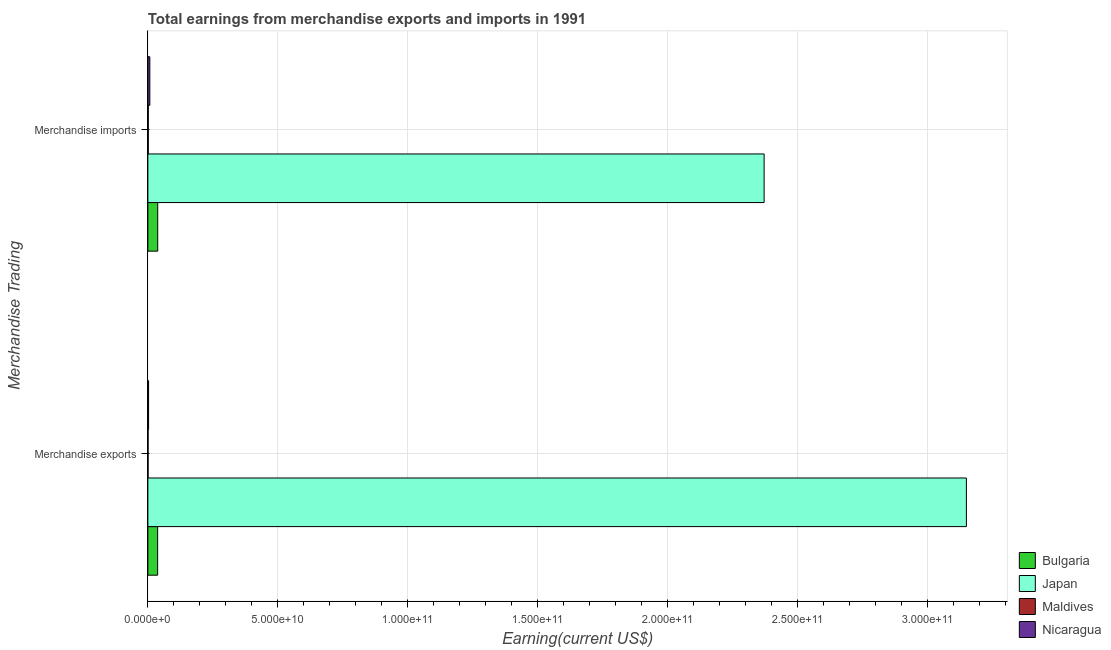How many different coloured bars are there?
Provide a short and direct response. 4. How many groups of bars are there?
Offer a terse response. 2. How many bars are there on the 1st tick from the bottom?
Ensure brevity in your answer.  4. What is the earnings from merchandise exports in Japan?
Provide a short and direct response. 3.15e+11. Across all countries, what is the maximum earnings from merchandise exports?
Ensure brevity in your answer.  3.15e+11. Across all countries, what is the minimum earnings from merchandise imports?
Offer a terse response. 1.61e+08. In which country was the earnings from merchandise imports minimum?
Offer a terse response. Maldives. What is the total earnings from merchandise imports in the graph?
Give a very brief answer. 2.42e+11. What is the difference between the earnings from merchandise imports in Maldives and that in Bulgaria?
Provide a succinct answer. -3.63e+09. What is the difference between the earnings from merchandise exports in Japan and the earnings from merchandise imports in Maldives?
Your response must be concise. 3.15e+11. What is the average earnings from merchandise imports per country?
Give a very brief answer. 6.04e+1. What is the difference between the earnings from merchandise exports and earnings from merchandise imports in Japan?
Your answer should be compact. 7.78e+1. In how many countries, is the earnings from merchandise imports greater than 220000000000 US$?
Offer a terse response. 1. What is the ratio of the earnings from merchandise imports in Bulgaria to that in Japan?
Your answer should be very brief. 0.02. What does the 1st bar from the top in Merchandise imports represents?
Make the answer very short. Nicaragua. What does the 4th bar from the bottom in Merchandise exports represents?
Your answer should be compact. Nicaragua. How many countries are there in the graph?
Your answer should be compact. 4. Does the graph contain any zero values?
Your answer should be very brief. No. What is the title of the graph?
Ensure brevity in your answer.  Total earnings from merchandise exports and imports in 1991. Does "Samoa" appear as one of the legend labels in the graph?
Ensure brevity in your answer.  No. What is the label or title of the X-axis?
Make the answer very short. Earning(current US$). What is the label or title of the Y-axis?
Offer a very short reply. Merchandise Trading. What is the Earning(current US$) in Bulgaria in Merchandise exports?
Make the answer very short. 3.76e+09. What is the Earning(current US$) of Japan in Merchandise exports?
Give a very brief answer. 3.15e+11. What is the Earning(current US$) in Maldives in Merchandise exports?
Offer a terse response. 7.62e+07. What is the Earning(current US$) of Nicaragua in Merchandise exports?
Your response must be concise. 2.72e+08. What is the Earning(current US$) of Bulgaria in Merchandise imports?
Provide a succinct answer. 3.79e+09. What is the Earning(current US$) of Japan in Merchandise imports?
Make the answer very short. 2.37e+11. What is the Earning(current US$) in Maldives in Merchandise imports?
Provide a short and direct response. 1.61e+08. What is the Earning(current US$) in Nicaragua in Merchandise imports?
Give a very brief answer. 7.51e+08. Across all Merchandise Trading, what is the maximum Earning(current US$) in Bulgaria?
Provide a succinct answer. 3.79e+09. Across all Merchandise Trading, what is the maximum Earning(current US$) of Japan?
Your answer should be very brief. 3.15e+11. Across all Merchandise Trading, what is the maximum Earning(current US$) in Maldives?
Provide a short and direct response. 1.61e+08. Across all Merchandise Trading, what is the maximum Earning(current US$) in Nicaragua?
Your answer should be very brief. 7.51e+08. Across all Merchandise Trading, what is the minimum Earning(current US$) of Bulgaria?
Make the answer very short. 3.76e+09. Across all Merchandise Trading, what is the minimum Earning(current US$) of Japan?
Offer a terse response. 2.37e+11. Across all Merchandise Trading, what is the minimum Earning(current US$) in Maldives?
Provide a succinct answer. 7.62e+07. Across all Merchandise Trading, what is the minimum Earning(current US$) of Nicaragua?
Make the answer very short. 2.72e+08. What is the total Earning(current US$) of Bulgaria in the graph?
Provide a short and direct response. 7.55e+09. What is the total Earning(current US$) of Japan in the graph?
Make the answer very short. 5.52e+11. What is the total Earning(current US$) in Maldives in the graph?
Your response must be concise. 2.37e+08. What is the total Earning(current US$) in Nicaragua in the graph?
Offer a terse response. 1.02e+09. What is the difference between the Earning(current US$) of Bulgaria in Merchandise exports and that in Merchandise imports?
Your response must be concise. -3.00e+07. What is the difference between the Earning(current US$) of Japan in Merchandise exports and that in Merchandise imports?
Offer a terse response. 7.78e+1. What is the difference between the Earning(current US$) of Maldives in Merchandise exports and that in Merchandise imports?
Your response must be concise. -8.48e+07. What is the difference between the Earning(current US$) of Nicaragua in Merchandise exports and that in Merchandise imports?
Provide a short and direct response. -4.79e+08. What is the difference between the Earning(current US$) in Bulgaria in Merchandise exports and the Earning(current US$) in Japan in Merchandise imports?
Offer a terse response. -2.33e+11. What is the difference between the Earning(current US$) in Bulgaria in Merchandise exports and the Earning(current US$) in Maldives in Merchandise imports?
Your response must be concise. 3.60e+09. What is the difference between the Earning(current US$) of Bulgaria in Merchandise exports and the Earning(current US$) of Nicaragua in Merchandise imports?
Give a very brief answer. 3.01e+09. What is the difference between the Earning(current US$) of Japan in Merchandise exports and the Earning(current US$) of Maldives in Merchandise imports?
Offer a very short reply. 3.15e+11. What is the difference between the Earning(current US$) in Japan in Merchandise exports and the Earning(current US$) in Nicaragua in Merchandise imports?
Make the answer very short. 3.14e+11. What is the difference between the Earning(current US$) of Maldives in Merchandise exports and the Earning(current US$) of Nicaragua in Merchandise imports?
Ensure brevity in your answer.  -6.75e+08. What is the average Earning(current US$) in Bulgaria per Merchandise Trading?
Ensure brevity in your answer.  3.78e+09. What is the average Earning(current US$) in Japan per Merchandise Trading?
Give a very brief answer. 2.76e+11. What is the average Earning(current US$) in Maldives per Merchandise Trading?
Offer a very short reply. 1.19e+08. What is the average Earning(current US$) of Nicaragua per Merchandise Trading?
Offer a very short reply. 5.12e+08. What is the difference between the Earning(current US$) of Bulgaria and Earning(current US$) of Japan in Merchandise exports?
Provide a succinct answer. -3.11e+11. What is the difference between the Earning(current US$) of Bulgaria and Earning(current US$) of Maldives in Merchandise exports?
Keep it short and to the point. 3.68e+09. What is the difference between the Earning(current US$) of Bulgaria and Earning(current US$) of Nicaragua in Merchandise exports?
Offer a terse response. 3.49e+09. What is the difference between the Earning(current US$) of Japan and Earning(current US$) of Maldives in Merchandise exports?
Offer a terse response. 3.15e+11. What is the difference between the Earning(current US$) of Japan and Earning(current US$) of Nicaragua in Merchandise exports?
Offer a terse response. 3.15e+11. What is the difference between the Earning(current US$) in Maldives and Earning(current US$) in Nicaragua in Merchandise exports?
Your answer should be very brief. -1.96e+08. What is the difference between the Earning(current US$) in Bulgaria and Earning(current US$) in Japan in Merchandise imports?
Your answer should be compact. -2.33e+11. What is the difference between the Earning(current US$) of Bulgaria and Earning(current US$) of Maldives in Merchandise imports?
Your response must be concise. 3.63e+09. What is the difference between the Earning(current US$) of Bulgaria and Earning(current US$) of Nicaragua in Merchandise imports?
Make the answer very short. 3.04e+09. What is the difference between the Earning(current US$) of Japan and Earning(current US$) of Maldives in Merchandise imports?
Give a very brief answer. 2.37e+11. What is the difference between the Earning(current US$) in Japan and Earning(current US$) in Nicaragua in Merchandise imports?
Provide a succinct answer. 2.36e+11. What is the difference between the Earning(current US$) in Maldives and Earning(current US$) in Nicaragua in Merchandise imports?
Your response must be concise. -5.90e+08. What is the ratio of the Earning(current US$) of Bulgaria in Merchandise exports to that in Merchandise imports?
Provide a short and direct response. 0.99. What is the ratio of the Earning(current US$) in Japan in Merchandise exports to that in Merchandise imports?
Your answer should be very brief. 1.33. What is the ratio of the Earning(current US$) in Maldives in Merchandise exports to that in Merchandise imports?
Keep it short and to the point. 0.47. What is the ratio of the Earning(current US$) of Nicaragua in Merchandise exports to that in Merchandise imports?
Make the answer very short. 0.36. What is the difference between the highest and the second highest Earning(current US$) in Bulgaria?
Your response must be concise. 3.00e+07. What is the difference between the highest and the second highest Earning(current US$) of Japan?
Offer a terse response. 7.78e+1. What is the difference between the highest and the second highest Earning(current US$) in Maldives?
Ensure brevity in your answer.  8.48e+07. What is the difference between the highest and the second highest Earning(current US$) in Nicaragua?
Offer a terse response. 4.79e+08. What is the difference between the highest and the lowest Earning(current US$) of Bulgaria?
Your response must be concise. 3.00e+07. What is the difference between the highest and the lowest Earning(current US$) of Japan?
Your answer should be compact. 7.78e+1. What is the difference between the highest and the lowest Earning(current US$) in Maldives?
Your answer should be very brief. 8.48e+07. What is the difference between the highest and the lowest Earning(current US$) in Nicaragua?
Keep it short and to the point. 4.79e+08. 